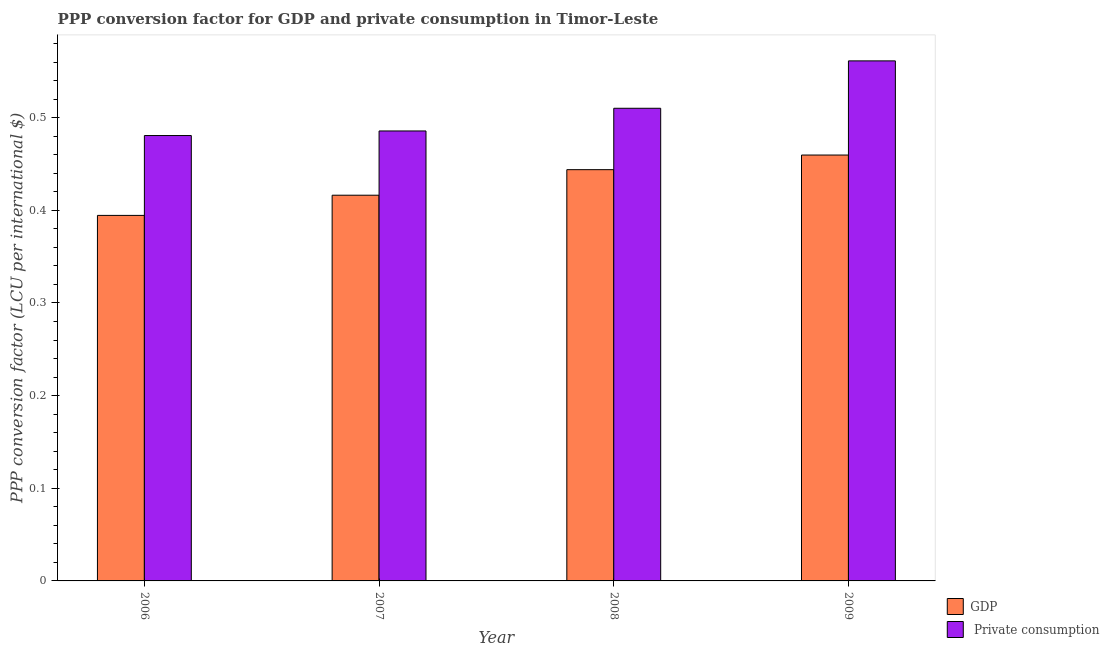How many groups of bars are there?
Keep it short and to the point. 4. Are the number of bars per tick equal to the number of legend labels?
Keep it short and to the point. Yes. Are the number of bars on each tick of the X-axis equal?
Ensure brevity in your answer.  Yes. What is the label of the 1st group of bars from the left?
Make the answer very short. 2006. What is the ppp conversion factor for gdp in 2007?
Provide a short and direct response. 0.42. Across all years, what is the maximum ppp conversion factor for private consumption?
Your answer should be compact. 0.56. Across all years, what is the minimum ppp conversion factor for gdp?
Keep it short and to the point. 0.39. In which year was the ppp conversion factor for private consumption minimum?
Provide a succinct answer. 2006. What is the total ppp conversion factor for gdp in the graph?
Give a very brief answer. 1.71. What is the difference between the ppp conversion factor for private consumption in 2006 and that in 2007?
Offer a terse response. -0. What is the difference between the ppp conversion factor for gdp in 2008 and the ppp conversion factor for private consumption in 2009?
Keep it short and to the point. -0.02. What is the average ppp conversion factor for private consumption per year?
Your response must be concise. 0.51. In the year 2006, what is the difference between the ppp conversion factor for private consumption and ppp conversion factor for gdp?
Give a very brief answer. 0. What is the ratio of the ppp conversion factor for private consumption in 2008 to that in 2009?
Offer a very short reply. 0.91. Is the ppp conversion factor for private consumption in 2006 less than that in 2007?
Your answer should be very brief. Yes. Is the difference between the ppp conversion factor for private consumption in 2006 and 2007 greater than the difference between the ppp conversion factor for gdp in 2006 and 2007?
Your answer should be very brief. No. What is the difference between the highest and the second highest ppp conversion factor for private consumption?
Your answer should be very brief. 0.05. What is the difference between the highest and the lowest ppp conversion factor for gdp?
Make the answer very short. 0.07. In how many years, is the ppp conversion factor for private consumption greater than the average ppp conversion factor for private consumption taken over all years?
Provide a succinct answer. 2. Is the sum of the ppp conversion factor for private consumption in 2006 and 2009 greater than the maximum ppp conversion factor for gdp across all years?
Make the answer very short. Yes. What does the 1st bar from the left in 2008 represents?
Provide a succinct answer. GDP. What does the 2nd bar from the right in 2009 represents?
Offer a very short reply. GDP. How many bars are there?
Offer a very short reply. 8. Are all the bars in the graph horizontal?
Provide a short and direct response. No. What is the difference between two consecutive major ticks on the Y-axis?
Provide a succinct answer. 0.1. Does the graph contain grids?
Keep it short and to the point. No. How many legend labels are there?
Provide a succinct answer. 2. How are the legend labels stacked?
Your answer should be compact. Vertical. What is the title of the graph?
Make the answer very short. PPP conversion factor for GDP and private consumption in Timor-Leste. What is the label or title of the X-axis?
Your answer should be very brief. Year. What is the label or title of the Y-axis?
Keep it short and to the point. PPP conversion factor (LCU per international $). What is the PPP conversion factor (LCU per international $) of GDP in 2006?
Keep it short and to the point. 0.39. What is the PPP conversion factor (LCU per international $) in  Private consumption in 2006?
Keep it short and to the point. 0.48. What is the PPP conversion factor (LCU per international $) of GDP in 2007?
Offer a terse response. 0.42. What is the PPP conversion factor (LCU per international $) in  Private consumption in 2007?
Provide a succinct answer. 0.49. What is the PPP conversion factor (LCU per international $) of GDP in 2008?
Make the answer very short. 0.44. What is the PPP conversion factor (LCU per international $) of  Private consumption in 2008?
Provide a succinct answer. 0.51. What is the PPP conversion factor (LCU per international $) of GDP in 2009?
Provide a succinct answer. 0.46. What is the PPP conversion factor (LCU per international $) in  Private consumption in 2009?
Your response must be concise. 0.56. Across all years, what is the maximum PPP conversion factor (LCU per international $) in GDP?
Keep it short and to the point. 0.46. Across all years, what is the maximum PPP conversion factor (LCU per international $) of  Private consumption?
Keep it short and to the point. 0.56. Across all years, what is the minimum PPP conversion factor (LCU per international $) in GDP?
Offer a very short reply. 0.39. Across all years, what is the minimum PPP conversion factor (LCU per international $) in  Private consumption?
Ensure brevity in your answer.  0.48. What is the total PPP conversion factor (LCU per international $) of GDP in the graph?
Offer a terse response. 1.71. What is the total PPP conversion factor (LCU per international $) in  Private consumption in the graph?
Your response must be concise. 2.04. What is the difference between the PPP conversion factor (LCU per international $) of GDP in 2006 and that in 2007?
Offer a terse response. -0.02. What is the difference between the PPP conversion factor (LCU per international $) in  Private consumption in 2006 and that in 2007?
Your answer should be very brief. -0. What is the difference between the PPP conversion factor (LCU per international $) in GDP in 2006 and that in 2008?
Give a very brief answer. -0.05. What is the difference between the PPP conversion factor (LCU per international $) of  Private consumption in 2006 and that in 2008?
Offer a terse response. -0.03. What is the difference between the PPP conversion factor (LCU per international $) of GDP in 2006 and that in 2009?
Provide a succinct answer. -0.07. What is the difference between the PPP conversion factor (LCU per international $) of  Private consumption in 2006 and that in 2009?
Offer a terse response. -0.08. What is the difference between the PPP conversion factor (LCU per international $) of GDP in 2007 and that in 2008?
Provide a succinct answer. -0.03. What is the difference between the PPP conversion factor (LCU per international $) of  Private consumption in 2007 and that in 2008?
Ensure brevity in your answer.  -0.02. What is the difference between the PPP conversion factor (LCU per international $) in GDP in 2007 and that in 2009?
Ensure brevity in your answer.  -0.04. What is the difference between the PPP conversion factor (LCU per international $) of  Private consumption in 2007 and that in 2009?
Offer a terse response. -0.08. What is the difference between the PPP conversion factor (LCU per international $) of GDP in 2008 and that in 2009?
Ensure brevity in your answer.  -0.02. What is the difference between the PPP conversion factor (LCU per international $) in  Private consumption in 2008 and that in 2009?
Provide a short and direct response. -0.05. What is the difference between the PPP conversion factor (LCU per international $) in GDP in 2006 and the PPP conversion factor (LCU per international $) in  Private consumption in 2007?
Provide a succinct answer. -0.09. What is the difference between the PPP conversion factor (LCU per international $) of GDP in 2006 and the PPP conversion factor (LCU per international $) of  Private consumption in 2008?
Your answer should be compact. -0.12. What is the difference between the PPP conversion factor (LCU per international $) of GDP in 2006 and the PPP conversion factor (LCU per international $) of  Private consumption in 2009?
Offer a very short reply. -0.17. What is the difference between the PPP conversion factor (LCU per international $) of GDP in 2007 and the PPP conversion factor (LCU per international $) of  Private consumption in 2008?
Your response must be concise. -0.09. What is the difference between the PPP conversion factor (LCU per international $) in GDP in 2007 and the PPP conversion factor (LCU per international $) in  Private consumption in 2009?
Offer a terse response. -0.14. What is the difference between the PPP conversion factor (LCU per international $) of GDP in 2008 and the PPP conversion factor (LCU per international $) of  Private consumption in 2009?
Your answer should be very brief. -0.12. What is the average PPP conversion factor (LCU per international $) in GDP per year?
Ensure brevity in your answer.  0.43. What is the average PPP conversion factor (LCU per international $) of  Private consumption per year?
Your response must be concise. 0.51. In the year 2006, what is the difference between the PPP conversion factor (LCU per international $) of GDP and PPP conversion factor (LCU per international $) of  Private consumption?
Your response must be concise. -0.09. In the year 2007, what is the difference between the PPP conversion factor (LCU per international $) in GDP and PPP conversion factor (LCU per international $) in  Private consumption?
Keep it short and to the point. -0.07. In the year 2008, what is the difference between the PPP conversion factor (LCU per international $) in GDP and PPP conversion factor (LCU per international $) in  Private consumption?
Offer a terse response. -0.07. In the year 2009, what is the difference between the PPP conversion factor (LCU per international $) of GDP and PPP conversion factor (LCU per international $) of  Private consumption?
Your response must be concise. -0.1. What is the ratio of the PPP conversion factor (LCU per international $) in GDP in 2006 to that in 2007?
Offer a terse response. 0.95. What is the ratio of the PPP conversion factor (LCU per international $) of GDP in 2006 to that in 2008?
Make the answer very short. 0.89. What is the ratio of the PPP conversion factor (LCU per international $) of  Private consumption in 2006 to that in 2008?
Keep it short and to the point. 0.94. What is the ratio of the PPP conversion factor (LCU per international $) in GDP in 2006 to that in 2009?
Offer a very short reply. 0.86. What is the ratio of the PPP conversion factor (LCU per international $) of  Private consumption in 2006 to that in 2009?
Your response must be concise. 0.86. What is the ratio of the PPP conversion factor (LCU per international $) in GDP in 2007 to that in 2008?
Make the answer very short. 0.94. What is the ratio of the PPP conversion factor (LCU per international $) in  Private consumption in 2007 to that in 2008?
Your answer should be compact. 0.95. What is the ratio of the PPP conversion factor (LCU per international $) in GDP in 2007 to that in 2009?
Ensure brevity in your answer.  0.91. What is the ratio of the PPP conversion factor (LCU per international $) in  Private consumption in 2007 to that in 2009?
Offer a terse response. 0.87. What is the ratio of the PPP conversion factor (LCU per international $) in GDP in 2008 to that in 2009?
Make the answer very short. 0.97. What is the ratio of the PPP conversion factor (LCU per international $) of  Private consumption in 2008 to that in 2009?
Your response must be concise. 0.91. What is the difference between the highest and the second highest PPP conversion factor (LCU per international $) of GDP?
Give a very brief answer. 0.02. What is the difference between the highest and the second highest PPP conversion factor (LCU per international $) in  Private consumption?
Offer a very short reply. 0.05. What is the difference between the highest and the lowest PPP conversion factor (LCU per international $) of GDP?
Provide a short and direct response. 0.07. What is the difference between the highest and the lowest PPP conversion factor (LCU per international $) in  Private consumption?
Your answer should be compact. 0.08. 